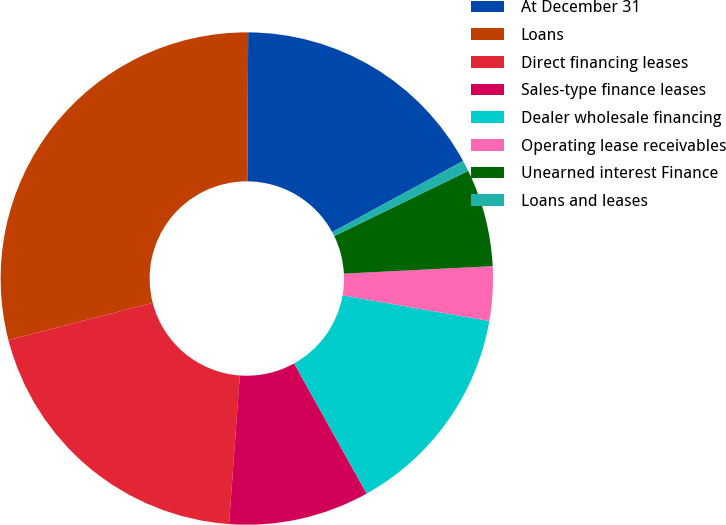<chart> <loc_0><loc_0><loc_500><loc_500><pie_chart><fcel>At December 31<fcel>Loans<fcel>Direct financing leases<fcel>Sales-type finance leases<fcel>Dealer wholesale financing<fcel>Operating lease receivables<fcel>Unearned interest Finance<fcel>Loans and leases<nl><fcel>16.99%<fcel>29.11%<fcel>19.83%<fcel>9.24%<fcel>14.15%<fcel>3.56%<fcel>6.4%<fcel>0.72%<nl></chart> 